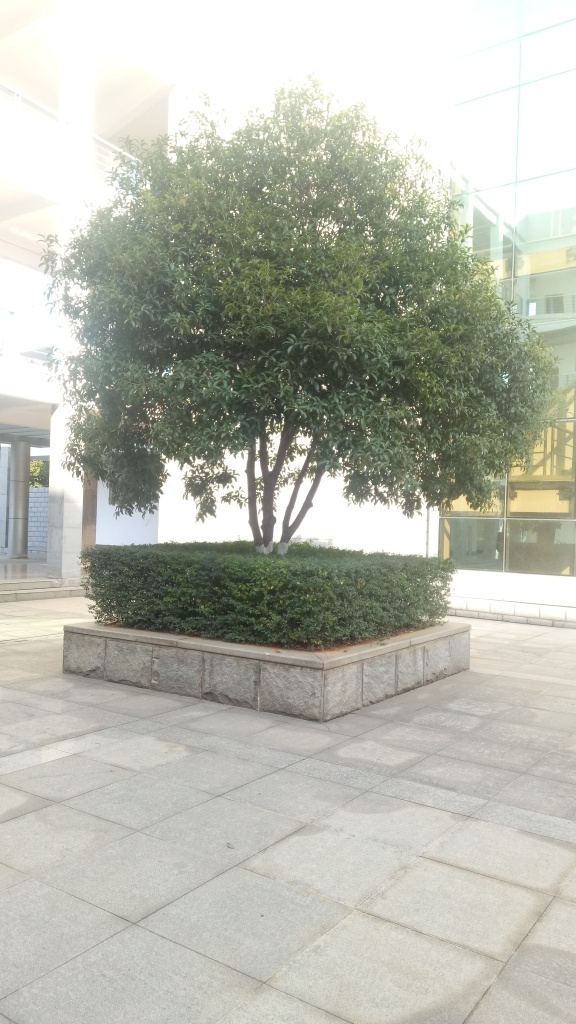Is the composition of the image poor? While the directness of the answer 'Yes' is clear, it lacks detail and justification. A more informative response would discuss specific elements that contribute to the composition's quality. For example, an enhanced answer might note the use of space, lighting, and the positioning of the central subject—the tree—within the frame. While the central placement of the tree may lack dynamism, the ample surrounding space and balance between the built and natural environments could be seen as providing a calming, symmetric aesthetic. Therefore, whether the composition is considered poor could be subjective, depending on the observer's preferences for photographic composition. 